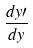<formula> <loc_0><loc_0><loc_500><loc_500>\frac { d y \prime } { d y }</formula> 